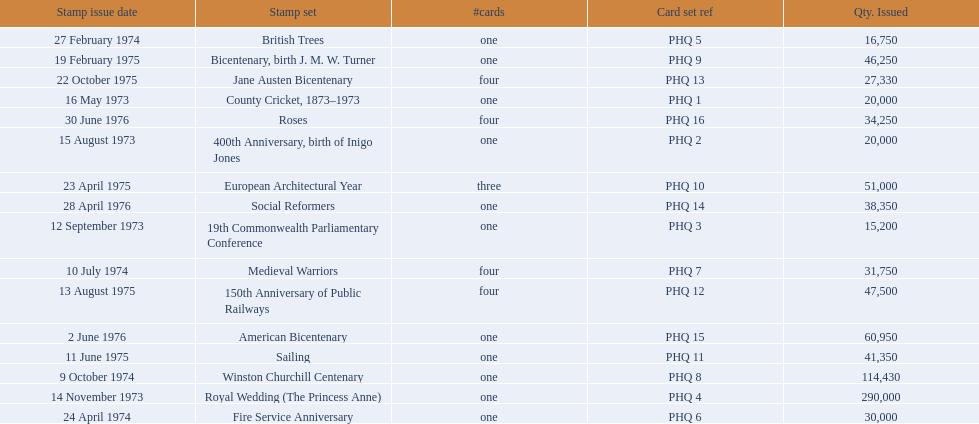Which stamp sets had three or more cards? Medieval Warriors, European Architectural Year, 150th Anniversary of Public Railways, Jane Austen Bicentenary, Roses. Of those, which one only has three cards? European Architectural Year. 